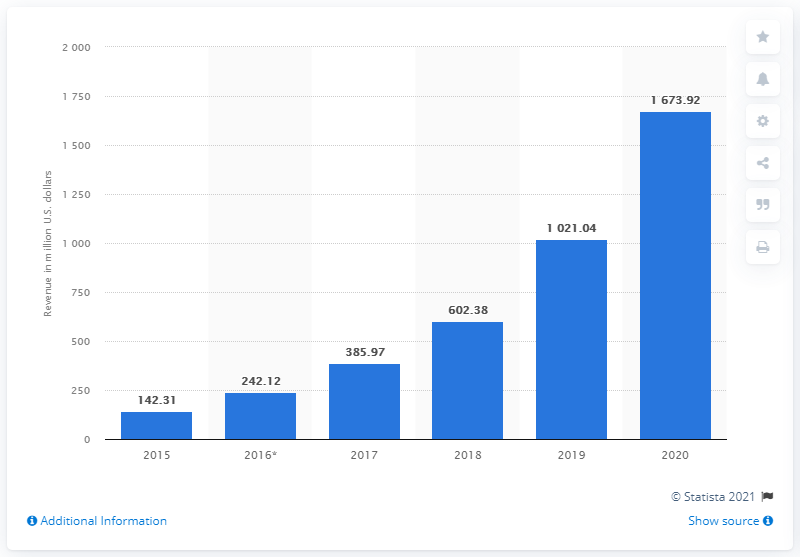Give some essential details in this illustration. Farfetch's sales revenue has increased significantly since 2015, with a growth of 142.31%. As of the latest recorded data, an estimated 142.31 people use Farfetch. 